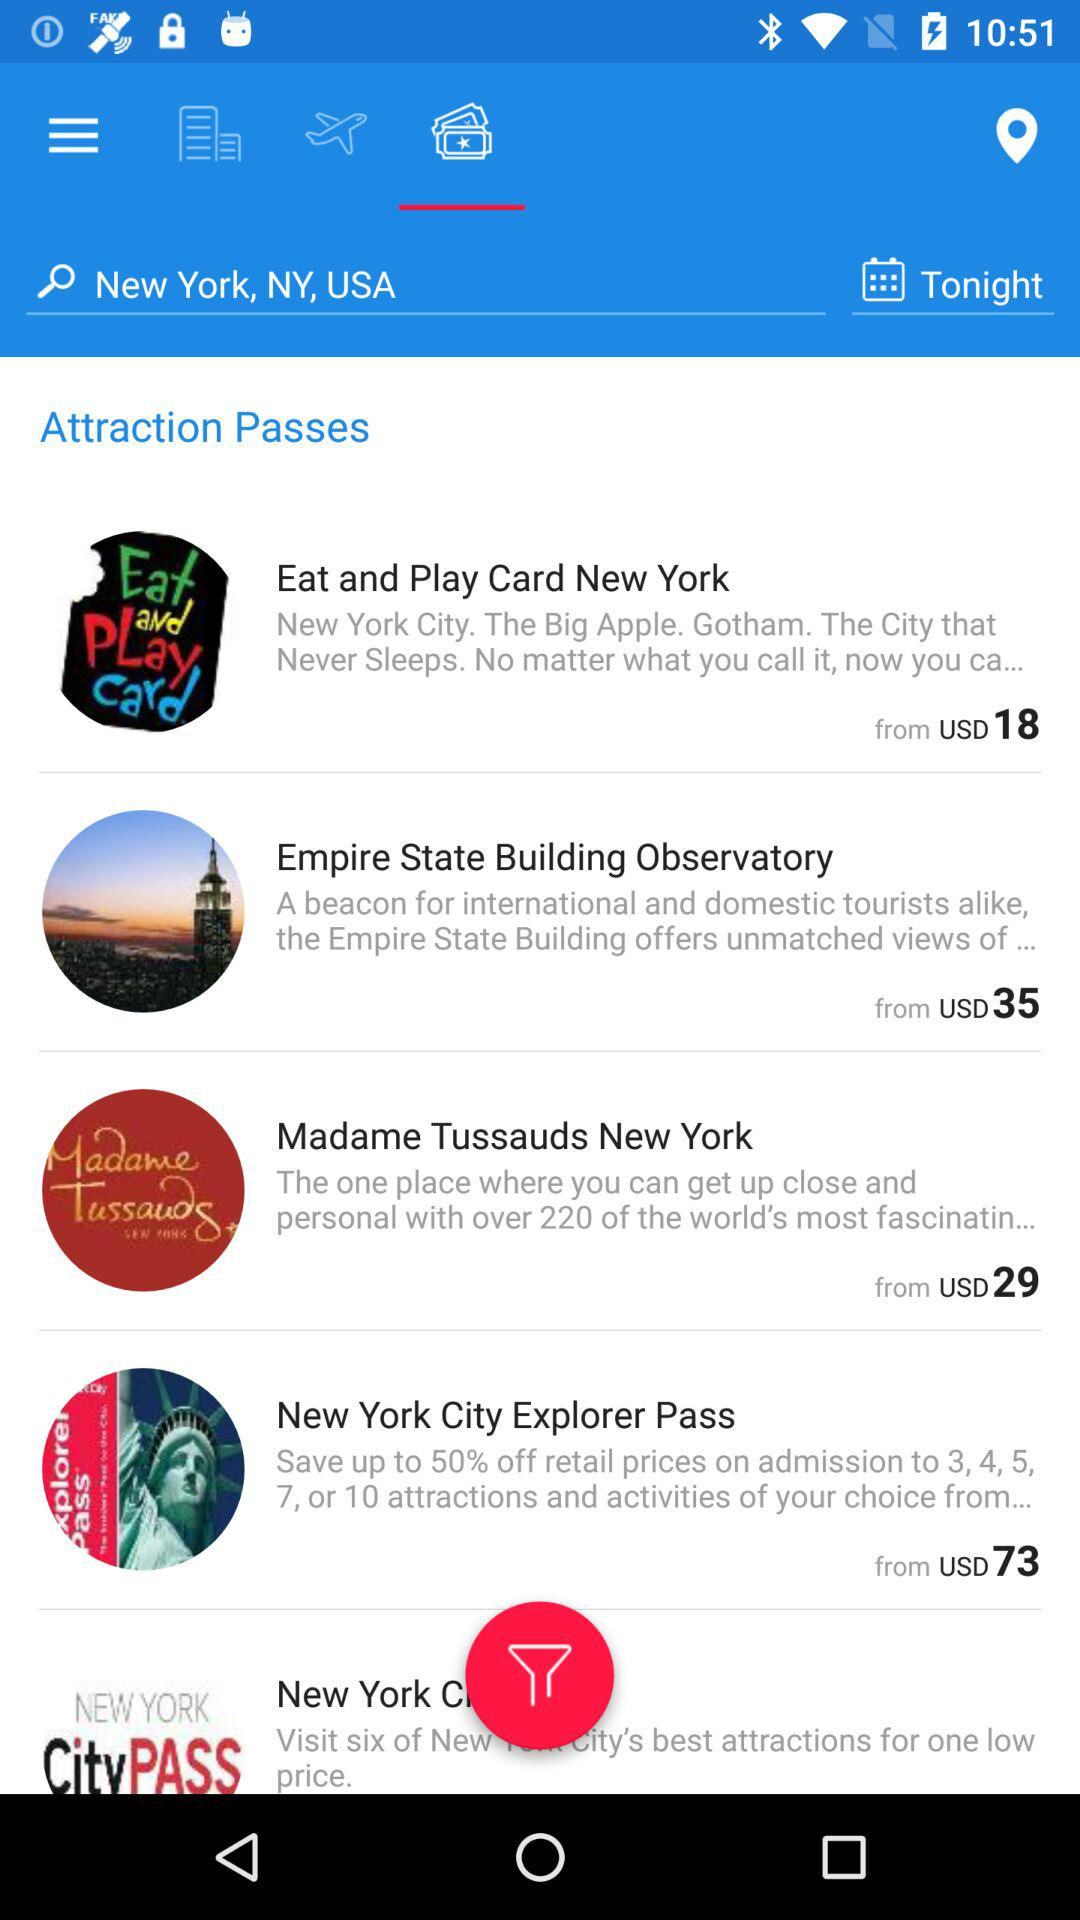What is the starting price of a "Madame Tussauds New York" pass? The starting price of a "Madame Tussauds New York" pass is USD 29. 